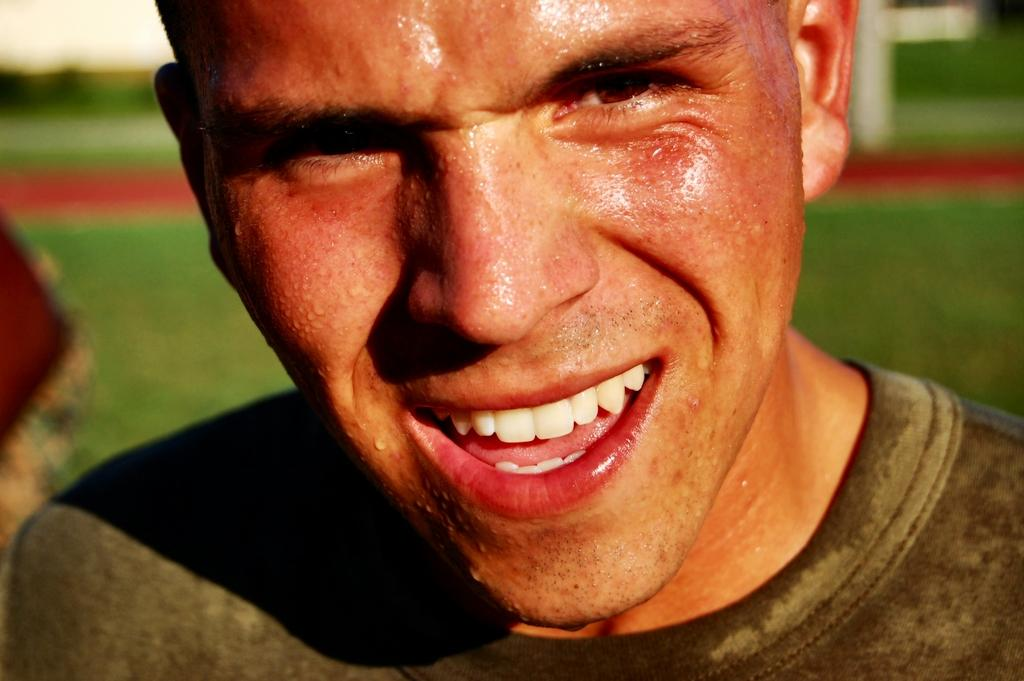Who is the main subject in the image? There is a man in the center of the image. What can be seen in the background of the image? The background appears to be a grassland. What book is the person holding in the image? There is no book present in the image; the main subject is a man standing in a grassland. 